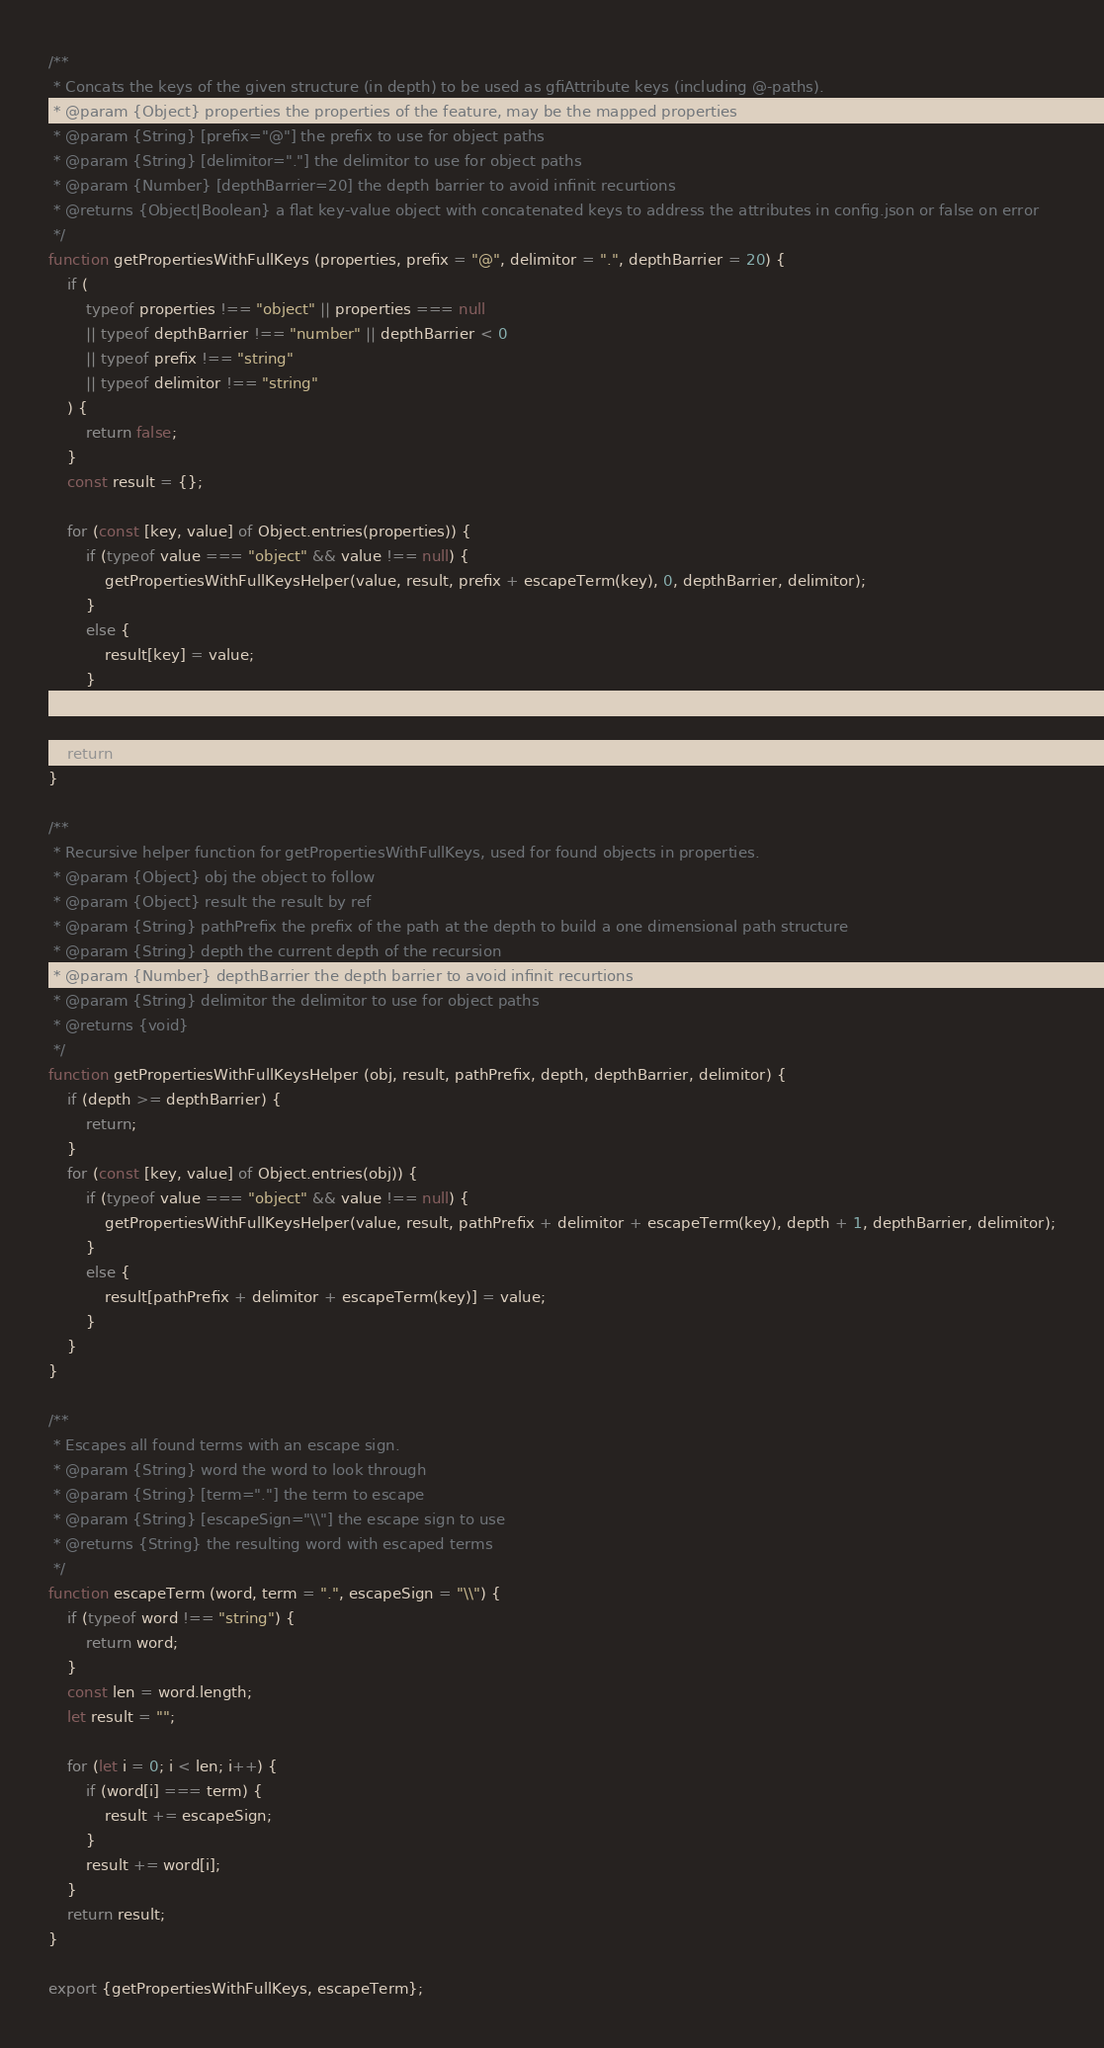Convert code to text. <code><loc_0><loc_0><loc_500><loc_500><_JavaScript_>/**
 * Concats the keys of the given structure (in depth) to be used as gfiAttribute keys (including @-paths).
 * @param {Object} properties the properties of the feature, may be the mapped properties
 * @param {String} [prefix="@"] the prefix to use for object paths
 * @param {String} [delimitor="."] the delimitor to use for object paths
 * @param {Number} [depthBarrier=20] the depth barrier to avoid infinit recurtions
 * @returns {Object|Boolean} a flat key-value object with concatenated keys to address the attributes in config.json or false on error
 */
function getPropertiesWithFullKeys (properties, prefix = "@", delimitor = ".", depthBarrier = 20) {
    if (
        typeof properties !== "object" || properties === null
        || typeof depthBarrier !== "number" || depthBarrier < 0
        || typeof prefix !== "string"
        || typeof delimitor !== "string"
    ) {
        return false;
    }
    const result = {};

    for (const [key, value] of Object.entries(properties)) {
        if (typeof value === "object" && value !== null) {
            getPropertiesWithFullKeysHelper(value, result, prefix + escapeTerm(key), 0, depthBarrier, delimitor);
        }
        else {
            result[key] = value;
        }
    }

    return result;
}

/**
 * Recursive helper function for getPropertiesWithFullKeys, used for found objects in properties.
 * @param {Object} obj the object to follow
 * @param {Object} result the result by ref
 * @param {String} pathPrefix the prefix of the path at the depth to build a one dimensional path structure
 * @param {String} depth the current depth of the recursion
 * @param {Number} depthBarrier the depth barrier to avoid infinit recurtions
 * @param {String} delimitor the delimitor to use for object paths
 * @returns {void}
 */
function getPropertiesWithFullKeysHelper (obj, result, pathPrefix, depth, depthBarrier, delimitor) {
    if (depth >= depthBarrier) {
        return;
    }
    for (const [key, value] of Object.entries(obj)) {
        if (typeof value === "object" && value !== null) {
            getPropertiesWithFullKeysHelper(value, result, pathPrefix + delimitor + escapeTerm(key), depth + 1, depthBarrier, delimitor);
        }
        else {
            result[pathPrefix + delimitor + escapeTerm(key)] = value;
        }
    }
}

/**
 * Escapes all found terms with an escape sign.
 * @param {String} word the word to look through
 * @param {String} [term="."] the term to escape
 * @param {String} [escapeSign="\\"] the escape sign to use
 * @returns {String} the resulting word with escaped terms
 */
function escapeTerm (word, term = ".", escapeSign = "\\") {
    if (typeof word !== "string") {
        return word;
    }
    const len = word.length;
    let result = "";

    for (let i = 0; i < len; i++) {
        if (word[i] === term) {
            result += escapeSign;
        }
        result += word[i];
    }
    return result;
}

export {getPropertiesWithFullKeys, escapeTerm};
</code> 